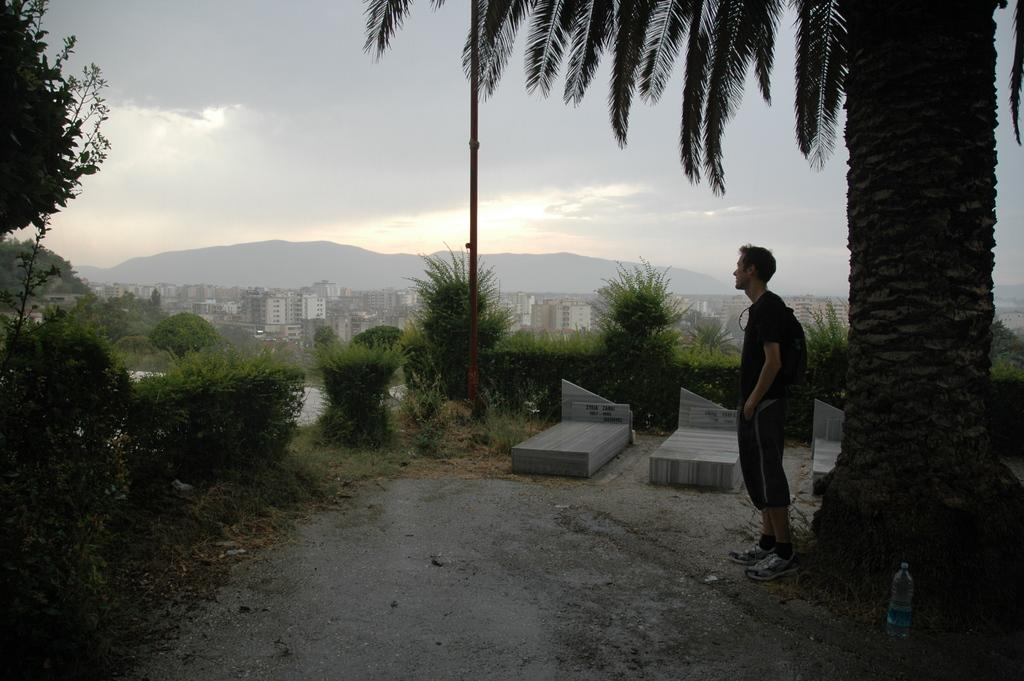Who is present in the image? There is a man in the image. What is the man doing in the image? The man is standing on a path. What is located next to the man? There is a tree next to the man. What can be seen in the background of the image? There are plants, trees, buildings, and the sky visible in the background of the image. What type of paper is the man holding in the image? There is no paper present in the image; the man is simply standing on a path next to a tree. 